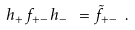Convert formula to latex. <formula><loc_0><loc_0><loc_500><loc_500>h _ { + } \, f _ { + - } \, h _ { - } \ = \tilde { f } _ { + - } \ .</formula> 